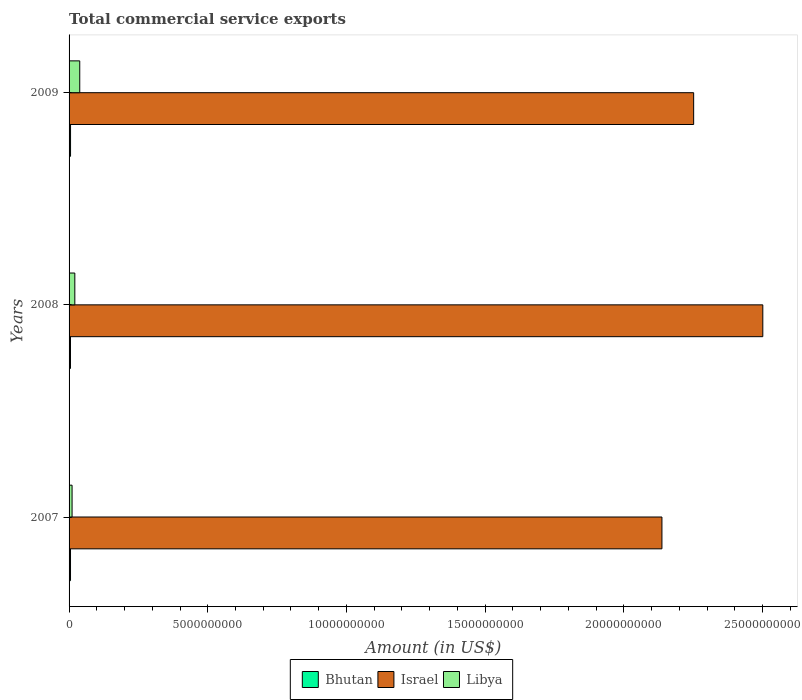How many different coloured bars are there?
Offer a very short reply. 3. Are the number of bars per tick equal to the number of legend labels?
Offer a very short reply. Yes. Are the number of bars on each tick of the Y-axis equal?
Make the answer very short. Yes. What is the label of the 2nd group of bars from the top?
Your response must be concise. 2008. What is the total commercial service exports in Libya in 2008?
Provide a succinct answer. 2.08e+08. Across all years, what is the maximum total commercial service exports in Bhutan?
Give a very brief answer. 5.33e+07. Across all years, what is the minimum total commercial service exports in Israel?
Provide a succinct answer. 2.14e+1. In which year was the total commercial service exports in Israel maximum?
Provide a short and direct response. 2008. In which year was the total commercial service exports in Bhutan minimum?
Provide a short and direct response. 2008. What is the total total commercial service exports in Israel in the graph?
Your response must be concise. 6.89e+1. What is the difference between the total commercial service exports in Bhutan in 2007 and that in 2009?
Make the answer very short. -1.45e+06. What is the difference between the total commercial service exports in Bhutan in 2008 and the total commercial service exports in Israel in 2007?
Your response must be concise. -2.13e+1. What is the average total commercial service exports in Libya per year?
Your response must be concise. 2.34e+08. In the year 2007, what is the difference between the total commercial service exports in Libya and total commercial service exports in Israel?
Ensure brevity in your answer.  -2.13e+1. What is the ratio of the total commercial service exports in Libya in 2007 to that in 2008?
Provide a succinct answer. 0.52. Is the total commercial service exports in Bhutan in 2007 less than that in 2008?
Keep it short and to the point. No. What is the difference between the highest and the second highest total commercial service exports in Libya?
Provide a succinct answer. 1.77e+08. What is the difference between the highest and the lowest total commercial service exports in Libya?
Your answer should be very brief. 2.76e+08. In how many years, is the total commercial service exports in Israel greater than the average total commercial service exports in Israel taken over all years?
Your response must be concise. 1. Is the sum of the total commercial service exports in Israel in 2007 and 2009 greater than the maximum total commercial service exports in Bhutan across all years?
Your answer should be very brief. Yes. What does the 1st bar from the top in 2007 represents?
Provide a short and direct response. Libya. What does the 3rd bar from the bottom in 2008 represents?
Make the answer very short. Libya. Is it the case that in every year, the sum of the total commercial service exports in Libya and total commercial service exports in Israel is greater than the total commercial service exports in Bhutan?
Provide a succinct answer. Yes. How many bars are there?
Keep it short and to the point. 9. Are all the bars in the graph horizontal?
Give a very brief answer. Yes. Does the graph contain grids?
Provide a succinct answer. No. How are the legend labels stacked?
Ensure brevity in your answer.  Horizontal. What is the title of the graph?
Offer a very short reply. Total commercial service exports. What is the label or title of the X-axis?
Make the answer very short. Amount (in US$). What is the Amount (in US$) of Bhutan in 2007?
Make the answer very short. 5.18e+07. What is the Amount (in US$) of Israel in 2007?
Provide a short and direct response. 2.14e+1. What is the Amount (in US$) in Libya in 2007?
Your response must be concise. 1.08e+08. What is the Amount (in US$) of Bhutan in 2008?
Your answer should be compact. 5.07e+07. What is the Amount (in US$) in Israel in 2008?
Make the answer very short. 2.50e+1. What is the Amount (in US$) in Libya in 2008?
Your answer should be compact. 2.08e+08. What is the Amount (in US$) in Bhutan in 2009?
Provide a succinct answer. 5.33e+07. What is the Amount (in US$) in Israel in 2009?
Ensure brevity in your answer.  2.25e+1. What is the Amount (in US$) in Libya in 2009?
Offer a very short reply. 3.85e+08. Across all years, what is the maximum Amount (in US$) in Bhutan?
Offer a terse response. 5.33e+07. Across all years, what is the maximum Amount (in US$) of Israel?
Your answer should be compact. 2.50e+1. Across all years, what is the maximum Amount (in US$) of Libya?
Keep it short and to the point. 3.85e+08. Across all years, what is the minimum Amount (in US$) in Bhutan?
Offer a terse response. 5.07e+07. Across all years, what is the minimum Amount (in US$) of Israel?
Your answer should be compact. 2.14e+1. Across all years, what is the minimum Amount (in US$) in Libya?
Provide a succinct answer. 1.08e+08. What is the total Amount (in US$) in Bhutan in the graph?
Provide a short and direct response. 1.56e+08. What is the total Amount (in US$) of Israel in the graph?
Keep it short and to the point. 6.89e+1. What is the total Amount (in US$) in Libya in the graph?
Keep it short and to the point. 7.01e+08. What is the difference between the Amount (in US$) in Bhutan in 2007 and that in 2008?
Keep it short and to the point. 1.08e+06. What is the difference between the Amount (in US$) in Israel in 2007 and that in 2008?
Offer a terse response. -3.64e+09. What is the difference between the Amount (in US$) in Libya in 2007 and that in 2008?
Make the answer very short. -9.92e+07. What is the difference between the Amount (in US$) in Bhutan in 2007 and that in 2009?
Provide a succinct answer. -1.45e+06. What is the difference between the Amount (in US$) of Israel in 2007 and that in 2009?
Ensure brevity in your answer.  -1.14e+09. What is the difference between the Amount (in US$) in Libya in 2007 and that in 2009?
Your answer should be compact. -2.76e+08. What is the difference between the Amount (in US$) of Bhutan in 2008 and that in 2009?
Give a very brief answer. -2.53e+06. What is the difference between the Amount (in US$) in Israel in 2008 and that in 2009?
Your answer should be very brief. 2.49e+09. What is the difference between the Amount (in US$) in Libya in 2008 and that in 2009?
Give a very brief answer. -1.77e+08. What is the difference between the Amount (in US$) of Bhutan in 2007 and the Amount (in US$) of Israel in 2008?
Offer a terse response. -2.50e+1. What is the difference between the Amount (in US$) in Bhutan in 2007 and the Amount (in US$) in Libya in 2008?
Your response must be concise. -1.56e+08. What is the difference between the Amount (in US$) in Israel in 2007 and the Amount (in US$) in Libya in 2008?
Your answer should be compact. 2.12e+1. What is the difference between the Amount (in US$) of Bhutan in 2007 and the Amount (in US$) of Israel in 2009?
Provide a succinct answer. -2.25e+1. What is the difference between the Amount (in US$) of Bhutan in 2007 and the Amount (in US$) of Libya in 2009?
Your answer should be compact. -3.33e+08. What is the difference between the Amount (in US$) of Israel in 2007 and the Amount (in US$) of Libya in 2009?
Give a very brief answer. 2.10e+1. What is the difference between the Amount (in US$) of Bhutan in 2008 and the Amount (in US$) of Israel in 2009?
Make the answer very short. -2.25e+1. What is the difference between the Amount (in US$) of Bhutan in 2008 and the Amount (in US$) of Libya in 2009?
Ensure brevity in your answer.  -3.34e+08. What is the difference between the Amount (in US$) of Israel in 2008 and the Amount (in US$) of Libya in 2009?
Give a very brief answer. 2.46e+1. What is the average Amount (in US$) of Bhutan per year?
Your answer should be very brief. 5.19e+07. What is the average Amount (in US$) in Israel per year?
Offer a very short reply. 2.30e+1. What is the average Amount (in US$) of Libya per year?
Give a very brief answer. 2.34e+08. In the year 2007, what is the difference between the Amount (in US$) in Bhutan and Amount (in US$) in Israel?
Provide a succinct answer. -2.13e+1. In the year 2007, what is the difference between the Amount (in US$) of Bhutan and Amount (in US$) of Libya?
Keep it short and to the point. -5.67e+07. In the year 2007, what is the difference between the Amount (in US$) of Israel and Amount (in US$) of Libya?
Provide a short and direct response. 2.13e+1. In the year 2008, what is the difference between the Amount (in US$) of Bhutan and Amount (in US$) of Israel?
Provide a succinct answer. -2.50e+1. In the year 2008, what is the difference between the Amount (in US$) in Bhutan and Amount (in US$) in Libya?
Give a very brief answer. -1.57e+08. In the year 2008, what is the difference between the Amount (in US$) in Israel and Amount (in US$) in Libya?
Make the answer very short. 2.48e+1. In the year 2009, what is the difference between the Amount (in US$) of Bhutan and Amount (in US$) of Israel?
Your response must be concise. -2.25e+1. In the year 2009, what is the difference between the Amount (in US$) of Bhutan and Amount (in US$) of Libya?
Offer a terse response. -3.32e+08. In the year 2009, what is the difference between the Amount (in US$) of Israel and Amount (in US$) of Libya?
Your answer should be very brief. 2.21e+1. What is the ratio of the Amount (in US$) in Bhutan in 2007 to that in 2008?
Provide a succinct answer. 1.02. What is the ratio of the Amount (in US$) in Israel in 2007 to that in 2008?
Provide a succinct answer. 0.85. What is the ratio of the Amount (in US$) of Libya in 2007 to that in 2008?
Your answer should be very brief. 0.52. What is the ratio of the Amount (in US$) of Bhutan in 2007 to that in 2009?
Give a very brief answer. 0.97. What is the ratio of the Amount (in US$) in Israel in 2007 to that in 2009?
Ensure brevity in your answer.  0.95. What is the ratio of the Amount (in US$) of Libya in 2007 to that in 2009?
Offer a terse response. 0.28. What is the ratio of the Amount (in US$) in Israel in 2008 to that in 2009?
Your response must be concise. 1.11. What is the ratio of the Amount (in US$) of Libya in 2008 to that in 2009?
Your response must be concise. 0.54. What is the difference between the highest and the second highest Amount (in US$) in Bhutan?
Provide a succinct answer. 1.45e+06. What is the difference between the highest and the second highest Amount (in US$) of Israel?
Provide a short and direct response. 2.49e+09. What is the difference between the highest and the second highest Amount (in US$) in Libya?
Make the answer very short. 1.77e+08. What is the difference between the highest and the lowest Amount (in US$) in Bhutan?
Provide a short and direct response. 2.53e+06. What is the difference between the highest and the lowest Amount (in US$) of Israel?
Keep it short and to the point. 3.64e+09. What is the difference between the highest and the lowest Amount (in US$) of Libya?
Provide a succinct answer. 2.76e+08. 